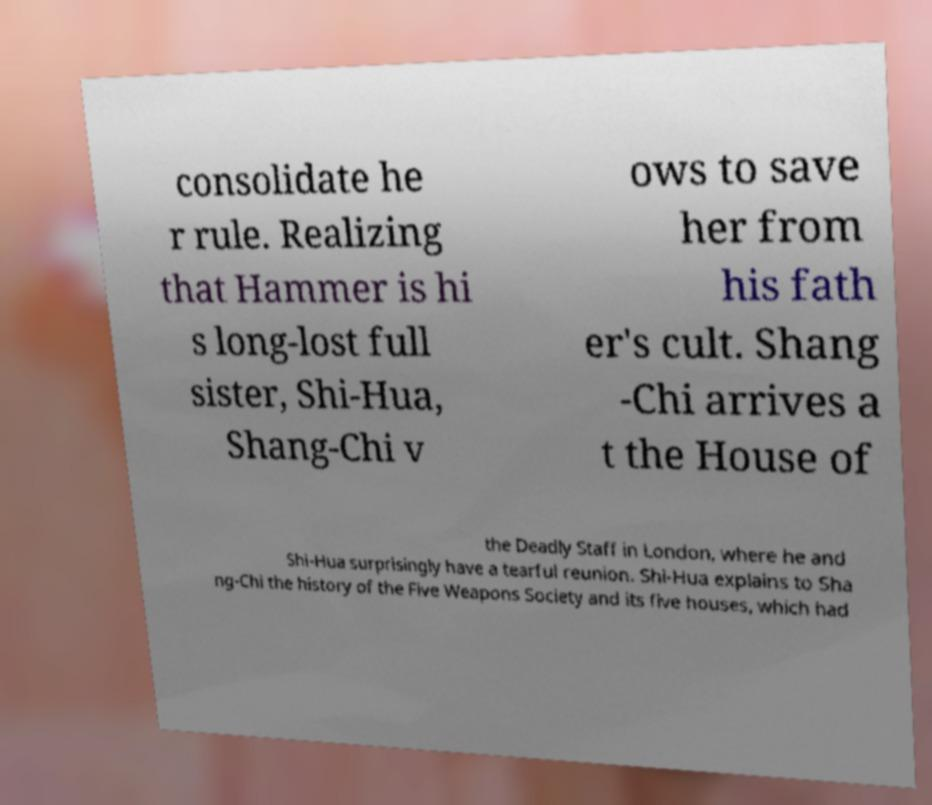Can you accurately transcribe the text from the provided image for me? consolidate he r rule. Realizing that Hammer is hi s long-lost full sister, Shi-Hua, Shang-Chi v ows to save her from his fath er's cult. Shang -Chi arrives a t the House of the Deadly Staff in London, where he and Shi-Hua surprisingly have a tearful reunion. Shi-Hua explains to Sha ng-Chi the history of the Five Weapons Society and its five houses, which had 